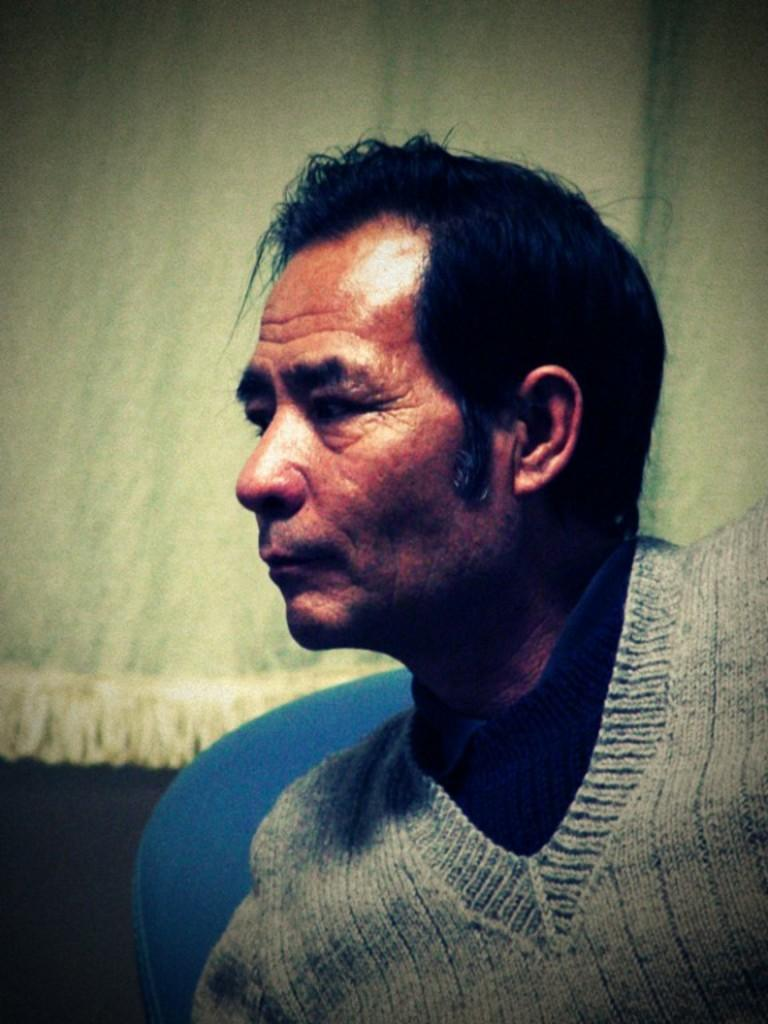Who or what is the main subject in the image? There is a person in the image. What object is visible behind the person? There is an object that looks like a chair behind the person. What can be seen in the background of the image? There is a curtain in the background of the image. What type of frog can be seen attacking the person in the image? There is no frog present in the image, and therefore no such attack can be observed. 